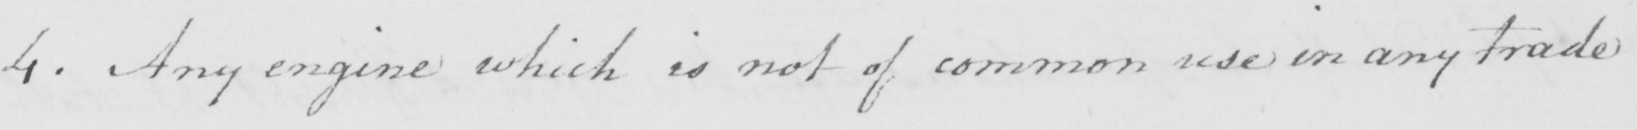What does this handwritten line say? 4 . Any engine which is not of common use in any trade 